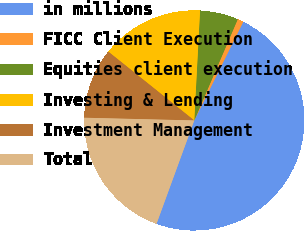Convert chart to OTSL. <chart><loc_0><loc_0><loc_500><loc_500><pie_chart><fcel>in millions<fcel>FICC Client Execution<fcel>Equities client execution<fcel>Investing & Lending<fcel>Investment Management<fcel>Total<nl><fcel>48.23%<fcel>0.88%<fcel>5.62%<fcel>15.09%<fcel>10.35%<fcel>19.82%<nl></chart> 